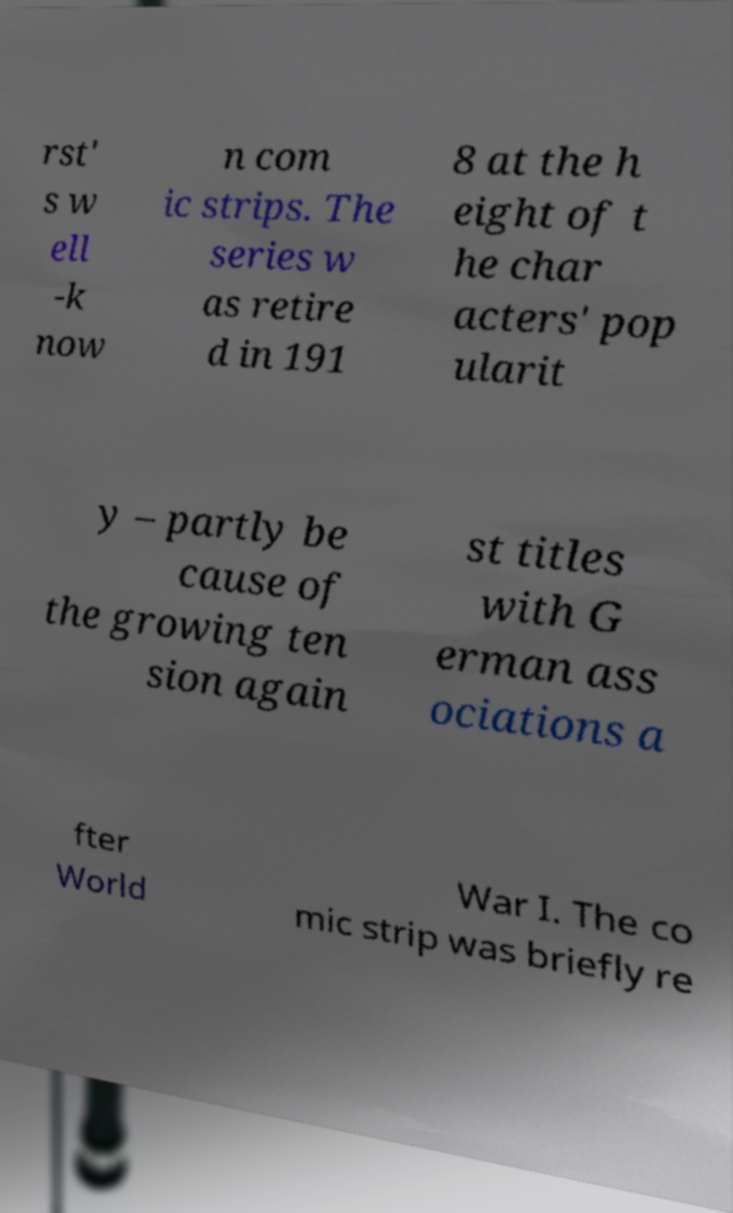There's text embedded in this image that I need extracted. Can you transcribe it verbatim? rst' s w ell -k now n com ic strips. The series w as retire d in 191 8 at the h eight of t he char acters' pop ularit y – partly be cause of the growing ten sion again st titles with G erman ass ociations a fter World War I. The co mic strip was briefly re 